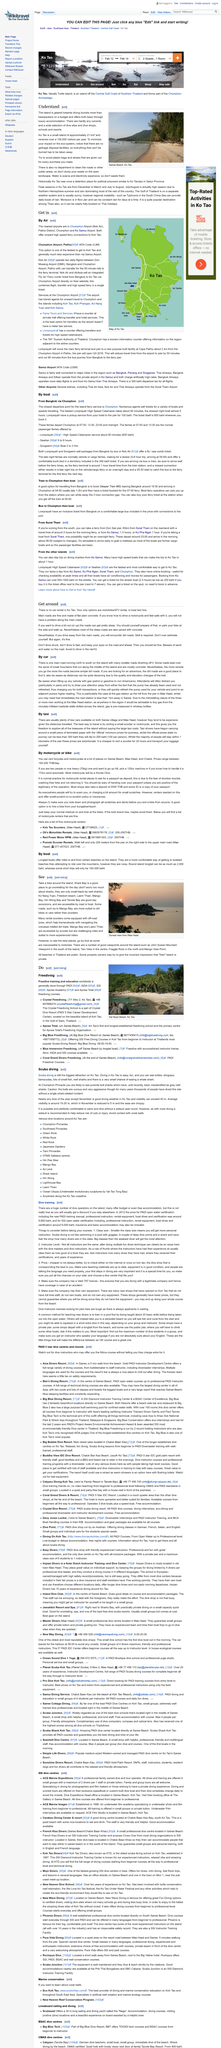Outline some significant characteristics in this image. In rural areas, roads often transition from paved surfaces to dirt roads as one travels further from urban centers. This transformation is most common in areas with limited infrastructure and development. The Crystal Freediving School is situated on the picturesque island of Koh Tao, offering breathtaking views of the crystal clear waters and lush tropical landscapes. In November, the weather is not conducive to diving as it is not a suitable diving month. Rental scooters are an ideal mode of transportation for navigating crevasse-riddled dirt trails, as they are sturdy and maneuverable, allowing individuals to safely traverse challenging terrain. PADI is the predominant organization responsible for providing freedive training and education worldwide. 